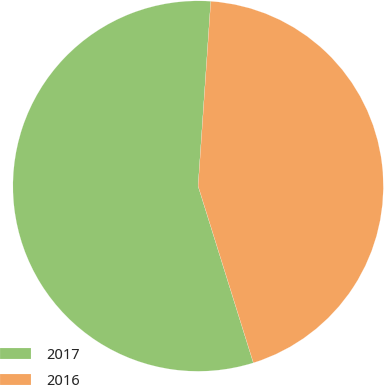Convert chart. <chart><loc_0><loc_0><loc_500><loc_500><pie_chart><fcel>2017<fcel>2016<nl><fcel>55.91%<fcel>44.09%<nl></chart> 